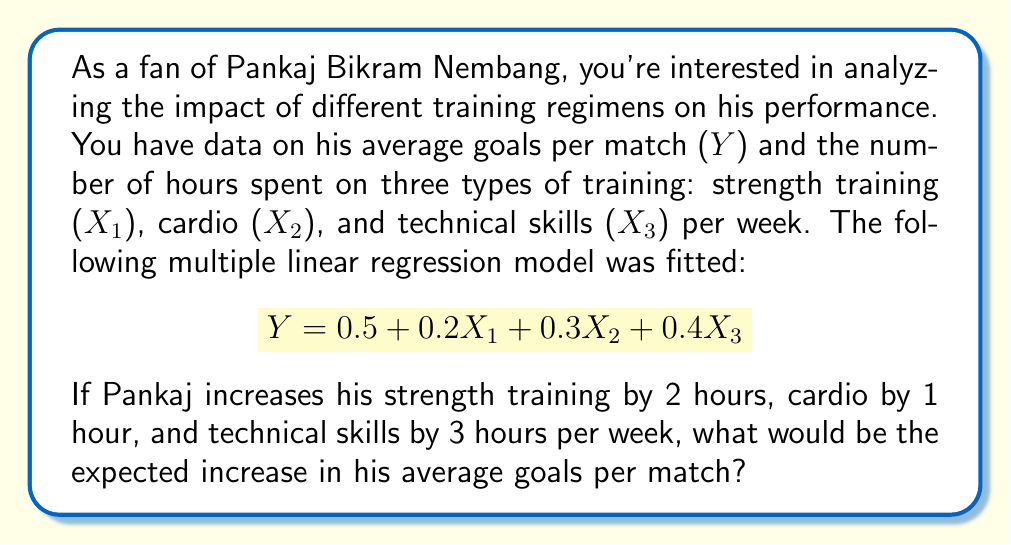What is the answer to this math problem? Let's approach this step-by-step:

1) The given regression equation is:
   $$Y = 0.5 + 0.2X_1 + 0.3X_2 + 0.4X_3$$

2) The coefficients represent the change in Y for a one-unit change in each X, holding other variables constant:
   - 0.2 for X₁ (strength training)
   - 0.3 for X₂ (cardio)
   - 0.4 for X₃ (technical skills)

3) Pankaj's proposed changes are:
   - Increase X₁ by 2 hours
   - Increase X₂ by 1 hour
   - Increase X₃ by 3 hours

4) To calculate the total expected increase, we multiply each coefficient by its respective change and sum the results:

   $$\Delta Y = 0.2(2) + 0.3(1) + 0.4(3)$$

5) Let's calculate each term:
   - 0.2(2) = 0.4
   - 0.3(1) = 0.3
   - 0.4(3) = 1.2

6) Now, sum these values:
   $$\Delta Y = 0.4 + 0.3 + 1.2 = 1.9$$

Therefore, the expected increase in Pankaj's average goals per match is 1.9.
Answer: 1.9 goals 